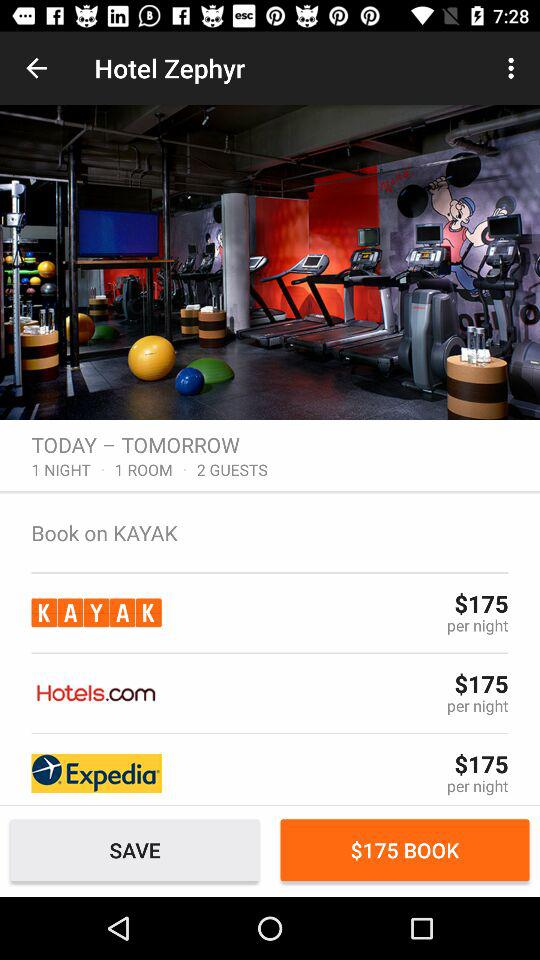What is the cost per night for hotels.com? The cost is $175. 